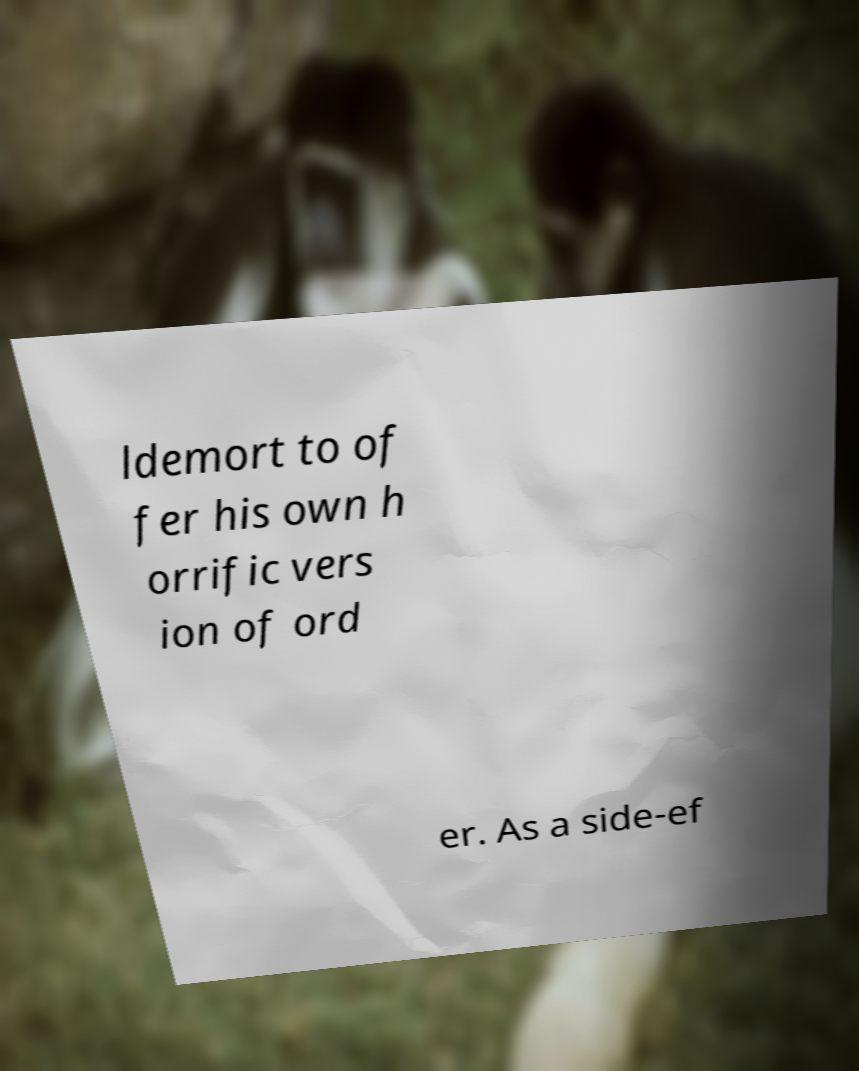There's text embedded in this image that I need extracted. Can you transcribe it verbatim? ldemort to of fer his own h orrific vers ion of ord er. As a side-ef 